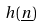Convert formula to latex. <formula><loc_0><loc_0><loc_500><loc_500>h ( \underline { n } )</formula> 